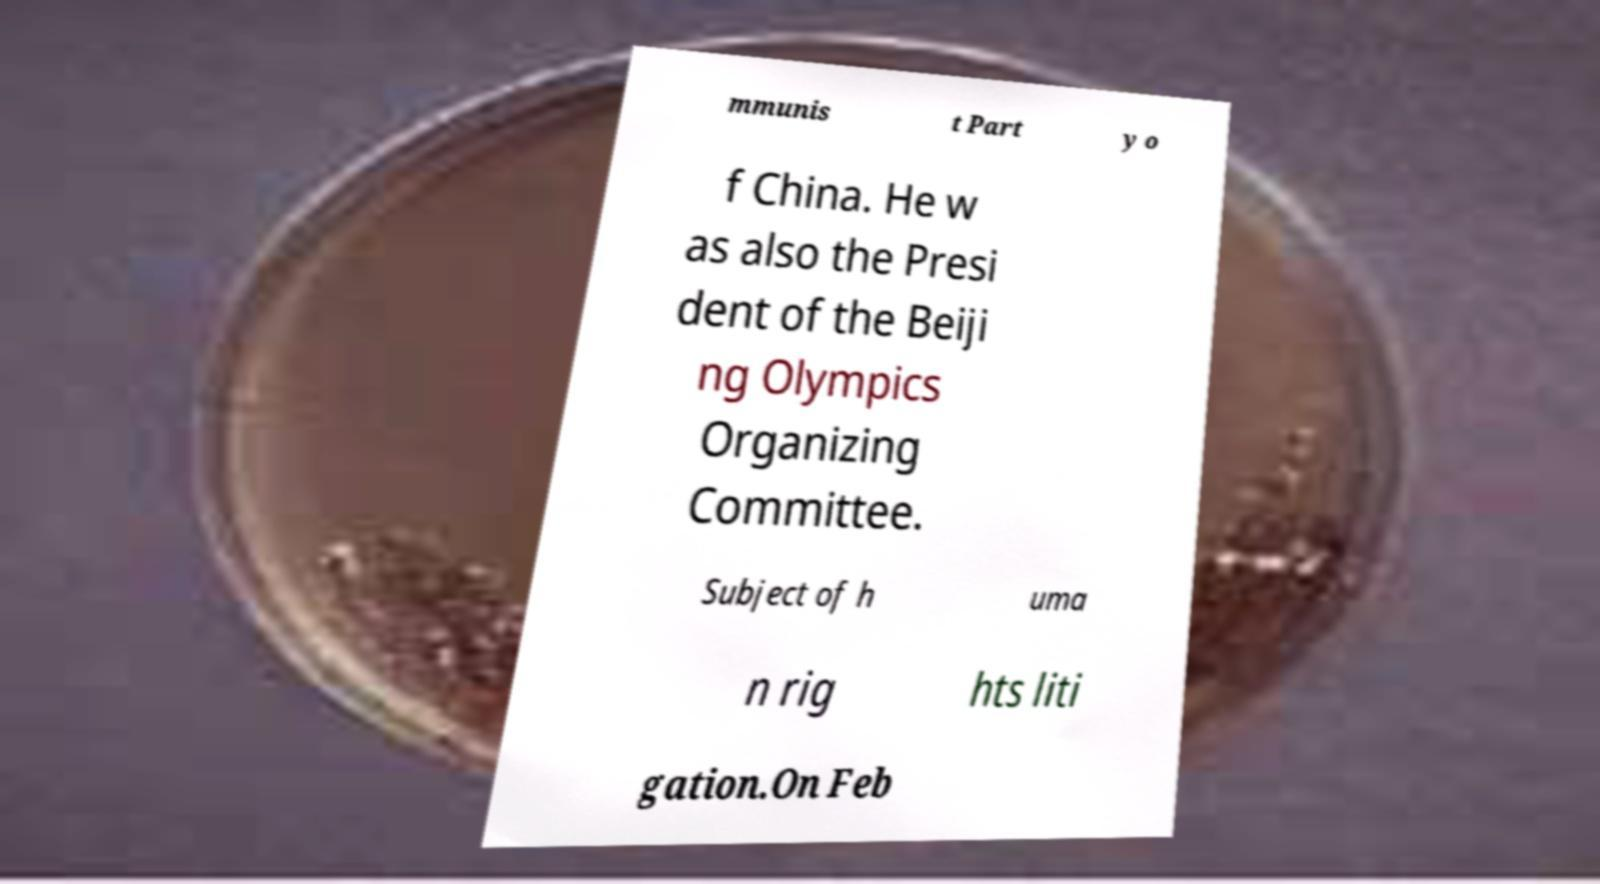Please read and relay the text visible in this image. What does it say? mmunis t Part y o f China. He w as also the Presi dent of the Beiji ng Olympics Organizing Committee. Subject of h uma n rig hts liti gation.On Feb 